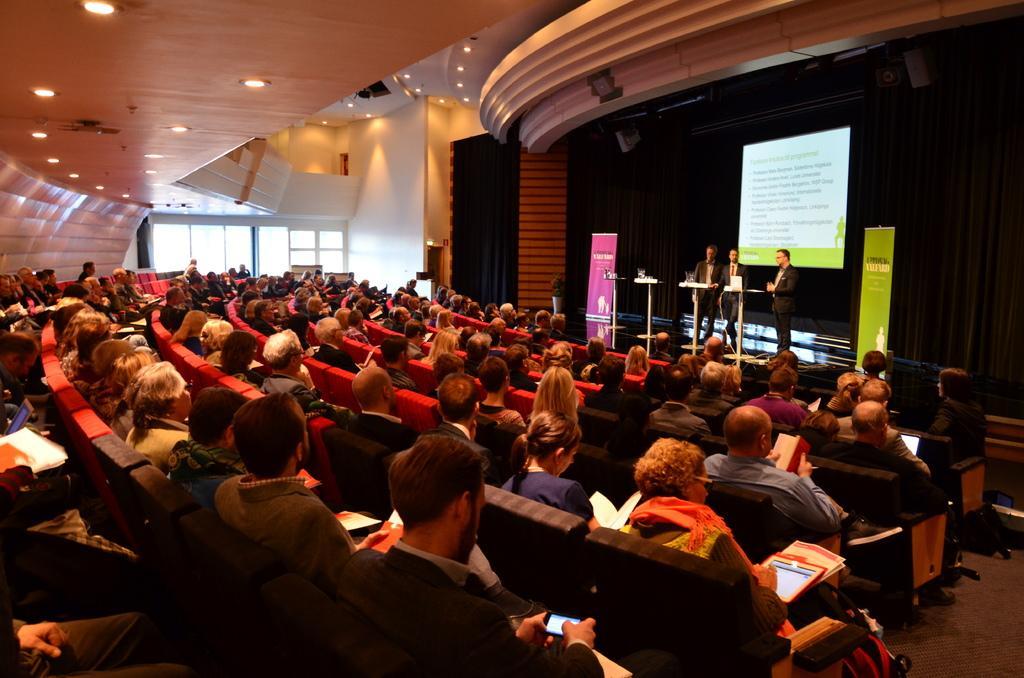Describe this image in one or two sentences. On the right side of the image we can see people standing and there are podiums. We can see boards and there is a screen. In the center there is crowd. At the top there are lights and there is a curtain. In the background there are windows. 